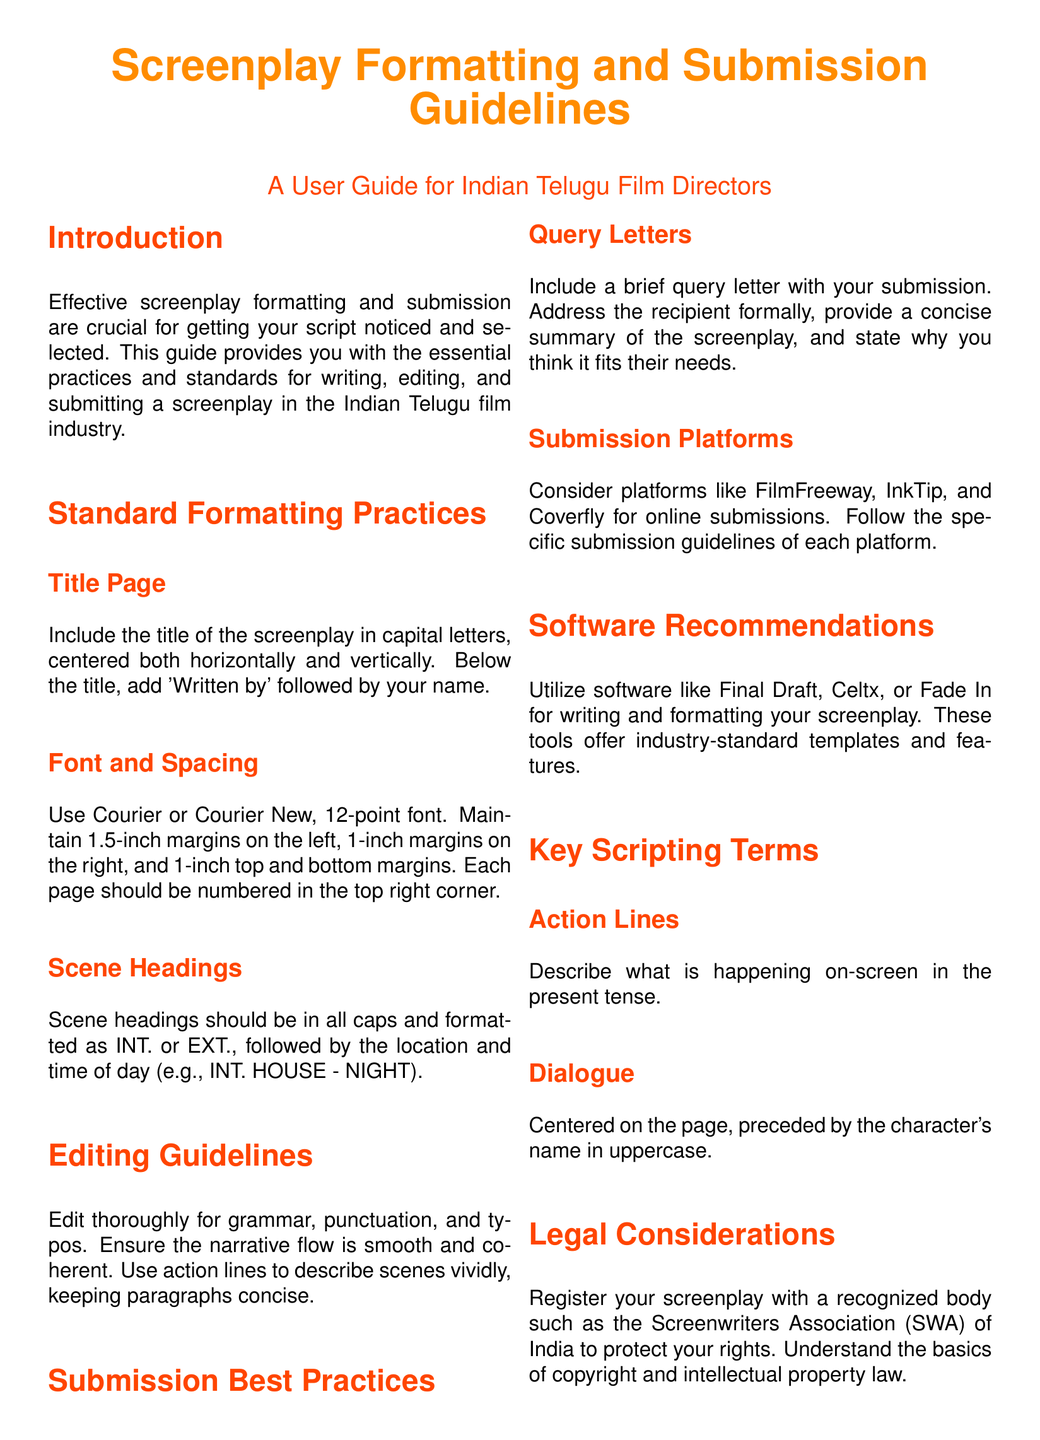What is the font recommended for screenplay writing? The document specifies using Courier or Courier New, 12-point font for screenplay writing.
Answer: Courier or Courier New What is the margin size on the left side of the screenplay? The guide states to maintain a 1.5-inch margin on the left side of the screenplay.
Answer: 1.5-inch What should be included on the title page? The title page should include the title of the screenplay in capital letters, centered, and 'Written by' followed by the author's name.
Answer: Title and 'Written by' with name Which platforms are suggested for online submissions? The document recommends platforms like FilmFreeway, InkTip, and Coverfly for online screenplay submissions.
Answer: FilmFreeway, InkTip, Coverfly What is the purpose of a query letter? A query letter should provide a concise summary of the screenplay and state why it fits the recipient's needs.
Answer: Concise summary and purpose fit What action lines describe in a screenplay? Action lines in a screenplay describe what is happening on-screen in the present tense.
Answer: Present tense actions What should the scene heading format include? Scene headings should include INT. or EXT., followed by the location and time of day.
Answer: INT. or EXT. with location and time How should dialogue be formatted? Dialogue should be centered on the page, preceded by the character's name in uppercase.
Answer: Centered with uppercase character name What is one legal consideration mentioned for screenwriters? The guide advises registering your screenplay with a recognized body to protect your rights.
Answer: Register with a recognized body 